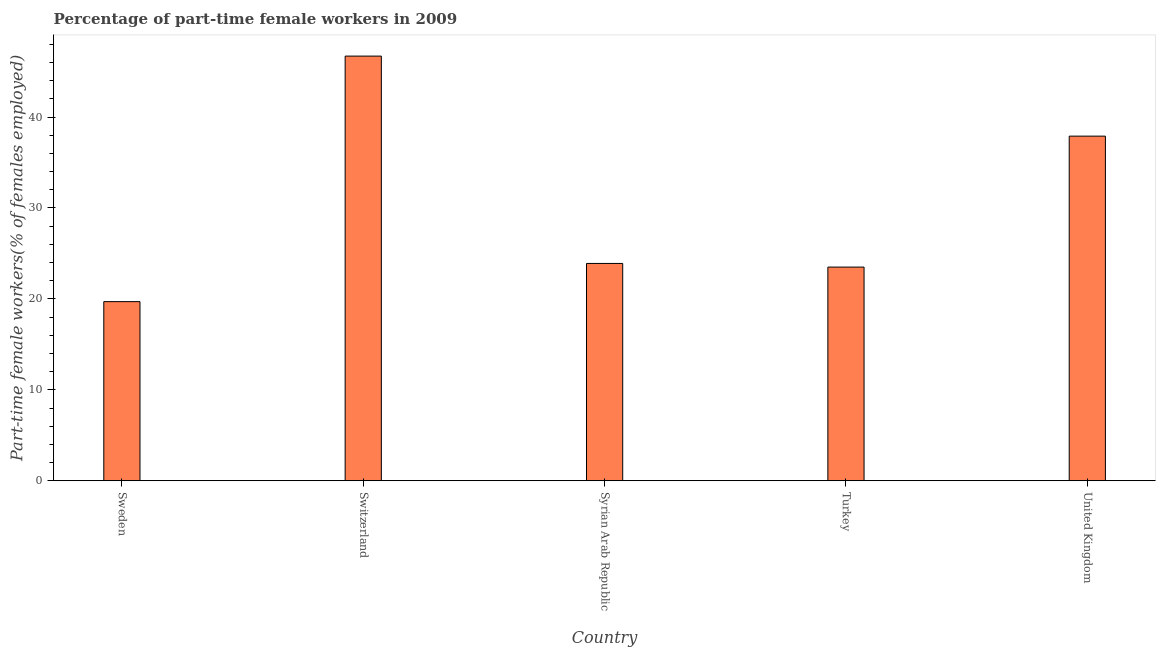Does the graph contain grids?
Provide a short and direct response. No. What is the title of the graph?
Give a very brief answer. Percentage of part-time female workers in 2009. What is the label or title of the Y-axis?
Give a very brief answer. Part-time female workers(% of females employed). What is the percentage of part-time female workers in Turkey?
Offer a very short reply. 23.5. Across all countries, what is the maximum percentage of part-time female workers?
Provide a short and direct response. 46.7. Across all countries, what is the minimum percentage of part-time female workers?
Your response must be concise. 19.7. In which country was the percentage of part-time female workers maximum?
Offer a terse response. Switzerland. What is the sum of the percentage of part-time female workers?
Your response must be concise. 151.7. What is the difference between the percentage of part-time female workers in Turkey and United Kingdom?
Your answer should be compact. -14.4. What is the average percentage of part-time female workers per country?
Keep it short and to the point. 30.34. What is the median percentage of part-time female workers?
Make the answer very short. 23.9. Is the percentage of part-time female workers in Sweden less than that in Syrian Arab Republic?
Provide a short and direct response. Yes. Is the difference between the percentage of part-time female workers in Switzerland and Turkey greater than the difference between any two countries?
Your answer should be compact. No. What is the difference between the highest and the lowest percentage of part-time female workers?
Keep it short and to the point. 27. How many countries are there in the graph?
Ensure brevity in your answer.  5. What is the Part-time female workers(% of females employed) in Sweden?
Provide a succinct answer. 19.7. What is the Part-time female workers(% of females employed) of Switzerland?
Your answer should be compact. 46.7. What is the Part-time female workers(% of females employed) of Syrian Arab Republic?
Ensure brevity in your answer.  23.9. What is the Part-time female workers(% of females employed) of United Kingdom?
Give a very brief answer. 37.9. What is the difference between the Part-time female workers(% of females employed) in Sweden and United Kingdom?
Ensure brevity in your answer.  -18.2. What is the difference between the Part-time female workers(% of females employed) in Switzerland and Syrian Arab Republic?
Offer a terse response. 22.8. What is the difference between the Part-time female workers(% of females employed) in Switzerland and Turkey?
Your answer should be compact. 23.2. What is the difference between the Part-time female workers(% of females employed) in Switzerland and United Kingdom?
Offer a terse response. 8.8. What is the difference between the Part-time female workers(% of females employed) in Syrian Arab Republic and Turkey?
Offer a terse response. 0.4. What is the difference between the Part-time female workers(% of females employed) in Syrian Arab Republic and United Kingdom?
Keep it short and to the point. -14. What is the difference between the Part-time female workers(% of females employed) in Turkey and United Kingdom?
Your answer should be compact. -14.4. What is the ratio of the Part-time female workers(% of females employed) in Sweden to that in Switzerland?
Your answer should be compact. 0.42. What is the ratio of the Part-time female workers(% of females employed) in Sweden to that in Syrian Arab Republic?
Your answer should be compact. 0.82. What is the ratio of the Part-time female workers(% of females employed) in Sweden to that in Turkey?
Ensure brevity in your answer.  0.84. What is the ratio of the Part-time female workers(% of females employed) in Sweden to that in United Kingdom?
Provide a succinct answer. 0.52. What is the ratio of the Part-time female workers(% of females employed) in Switzerland to that in Syrian Arab Republic?
Your answer should be compact. 1.95. What is the ratio of the Part-time female workers(% of females employed) in Switzerland to that in Turkey?
Provide a succinct answer. 1.99. What is the ratio of the Part-time female workers(% of females employed) in Switzerland to that in United Kingdom?
Provide a succinct answer. 1.23. What is the ratio of the Part-time female workers(% of females employed) in Syrian Arab Republic to that in United Kingdom?
Provide a short and direct response. 0.63. What is the ratio of the Part-time female workers(% of females employed) in Turkey to that in United Kingdom?
Offer a very short reply. 0.62. 